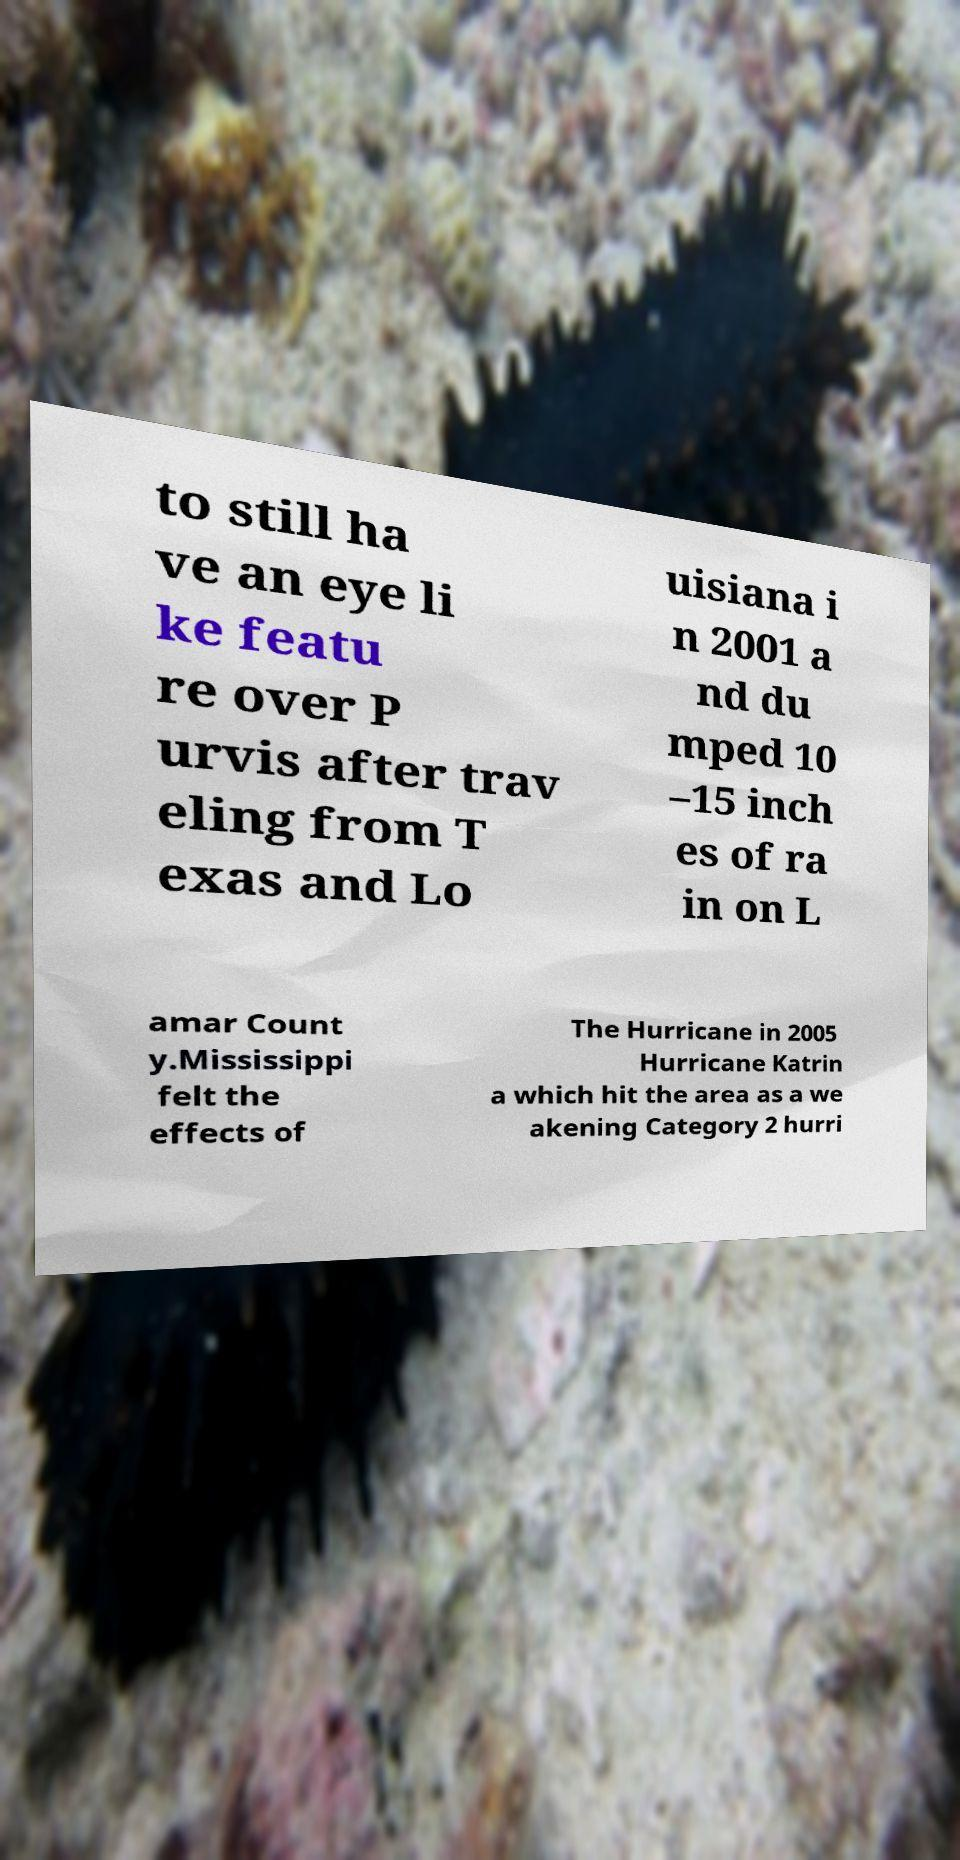I need the written content from this picture converted into text. Can you do that? to still ha ve an eye li ke featu re over P urvis after trav eling from T exas and Lo uisiana i n 2001 a nd du mped 10 –15 inch es of ra in on L amar Count y.Mississippi felt the effects of The Hurricane in 2005 Hurricane Katrin a which hit the area as a we akening Category 2 hurri 